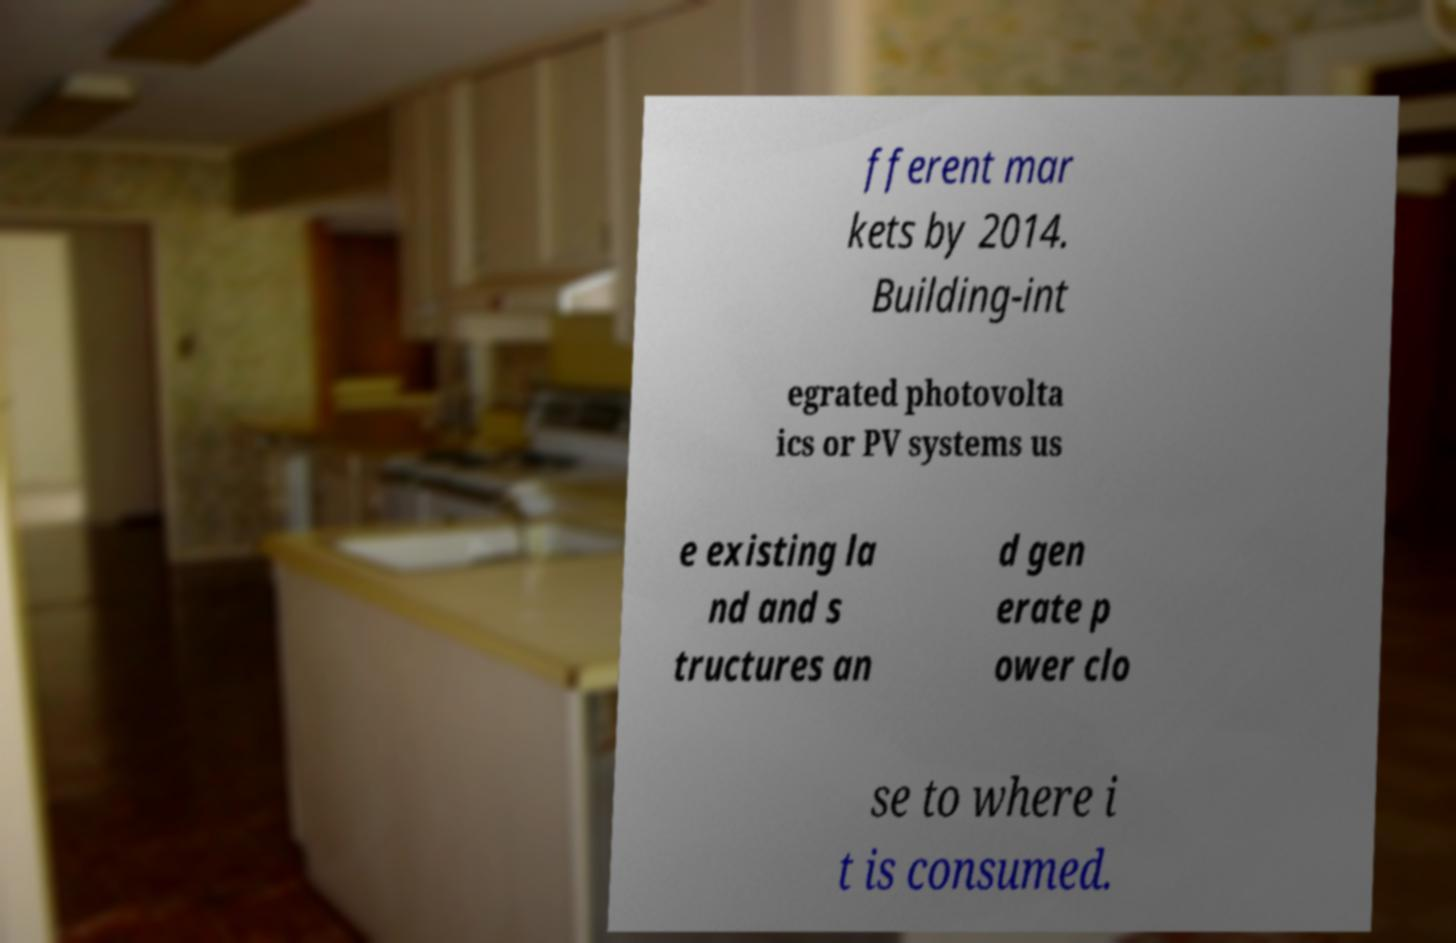Could you extract and type out the text from this image? fferent mar kets by 2014. Building-int egrated photovolta ics or PV systems us e existing la nd and s tructures an d gen erate p ower clo se to where i t is consumed. 